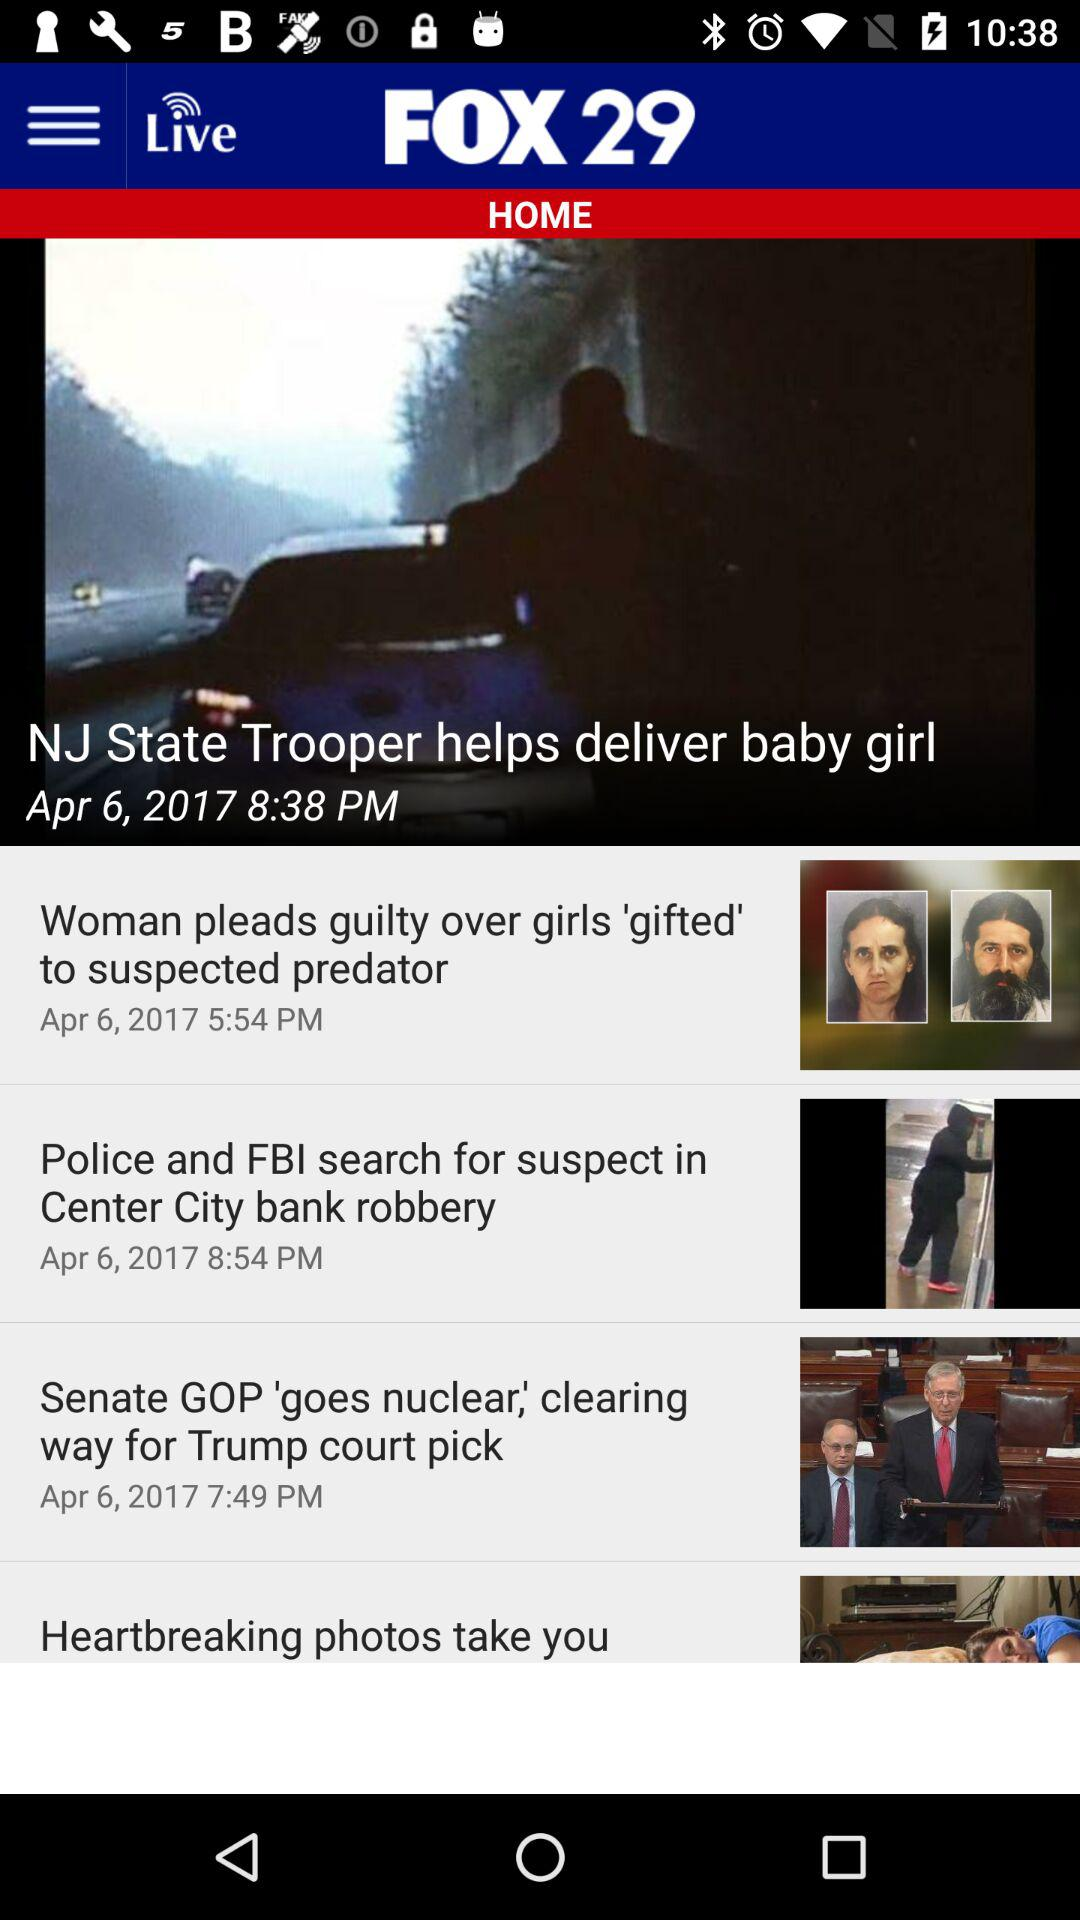On what date was the news that a NJ state trooper helped deliver a baby girl updated? The news about a NJ state trooper helping deliver a baby girl was updated on April 6, 2017. 